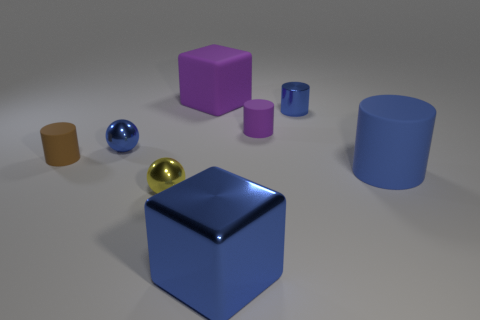Does the large shiny object have the same color as the big matte thing that is in front of the purple matte cube?
Your answer should be very brief. Yes. How many tiny blue spheres are the same material as the tiny brown object?
Your response must be concise. 0. The cylinder that is made of the same material as the small yellow ball is what color?
Your answer should be very brief. Blue. Do the brown rubber object and the rubber cylinder that is in front of the brown matte cylinder have the same size?
Make the answer very short. No. There is a small yellow object; what shape is it?
Give a very brief answer. Sphere. How many spheres have the same color as the rubber block?
Your answer should be compact. 0. What is the color of the metal object that is the same shape as the big blue rubber thing?
Provide a succinct answer. Blue. There is a tiny shiny sphere behind the brown cylinder; what number of matte things are on the left side of it?
Your answer should be very brief. 1. How many cylinders are small purple objects or big blue matte things?
Provide a short and direct response. 2. Is there a small purple matte cube?
Ensure brevity in your answer.  No. 